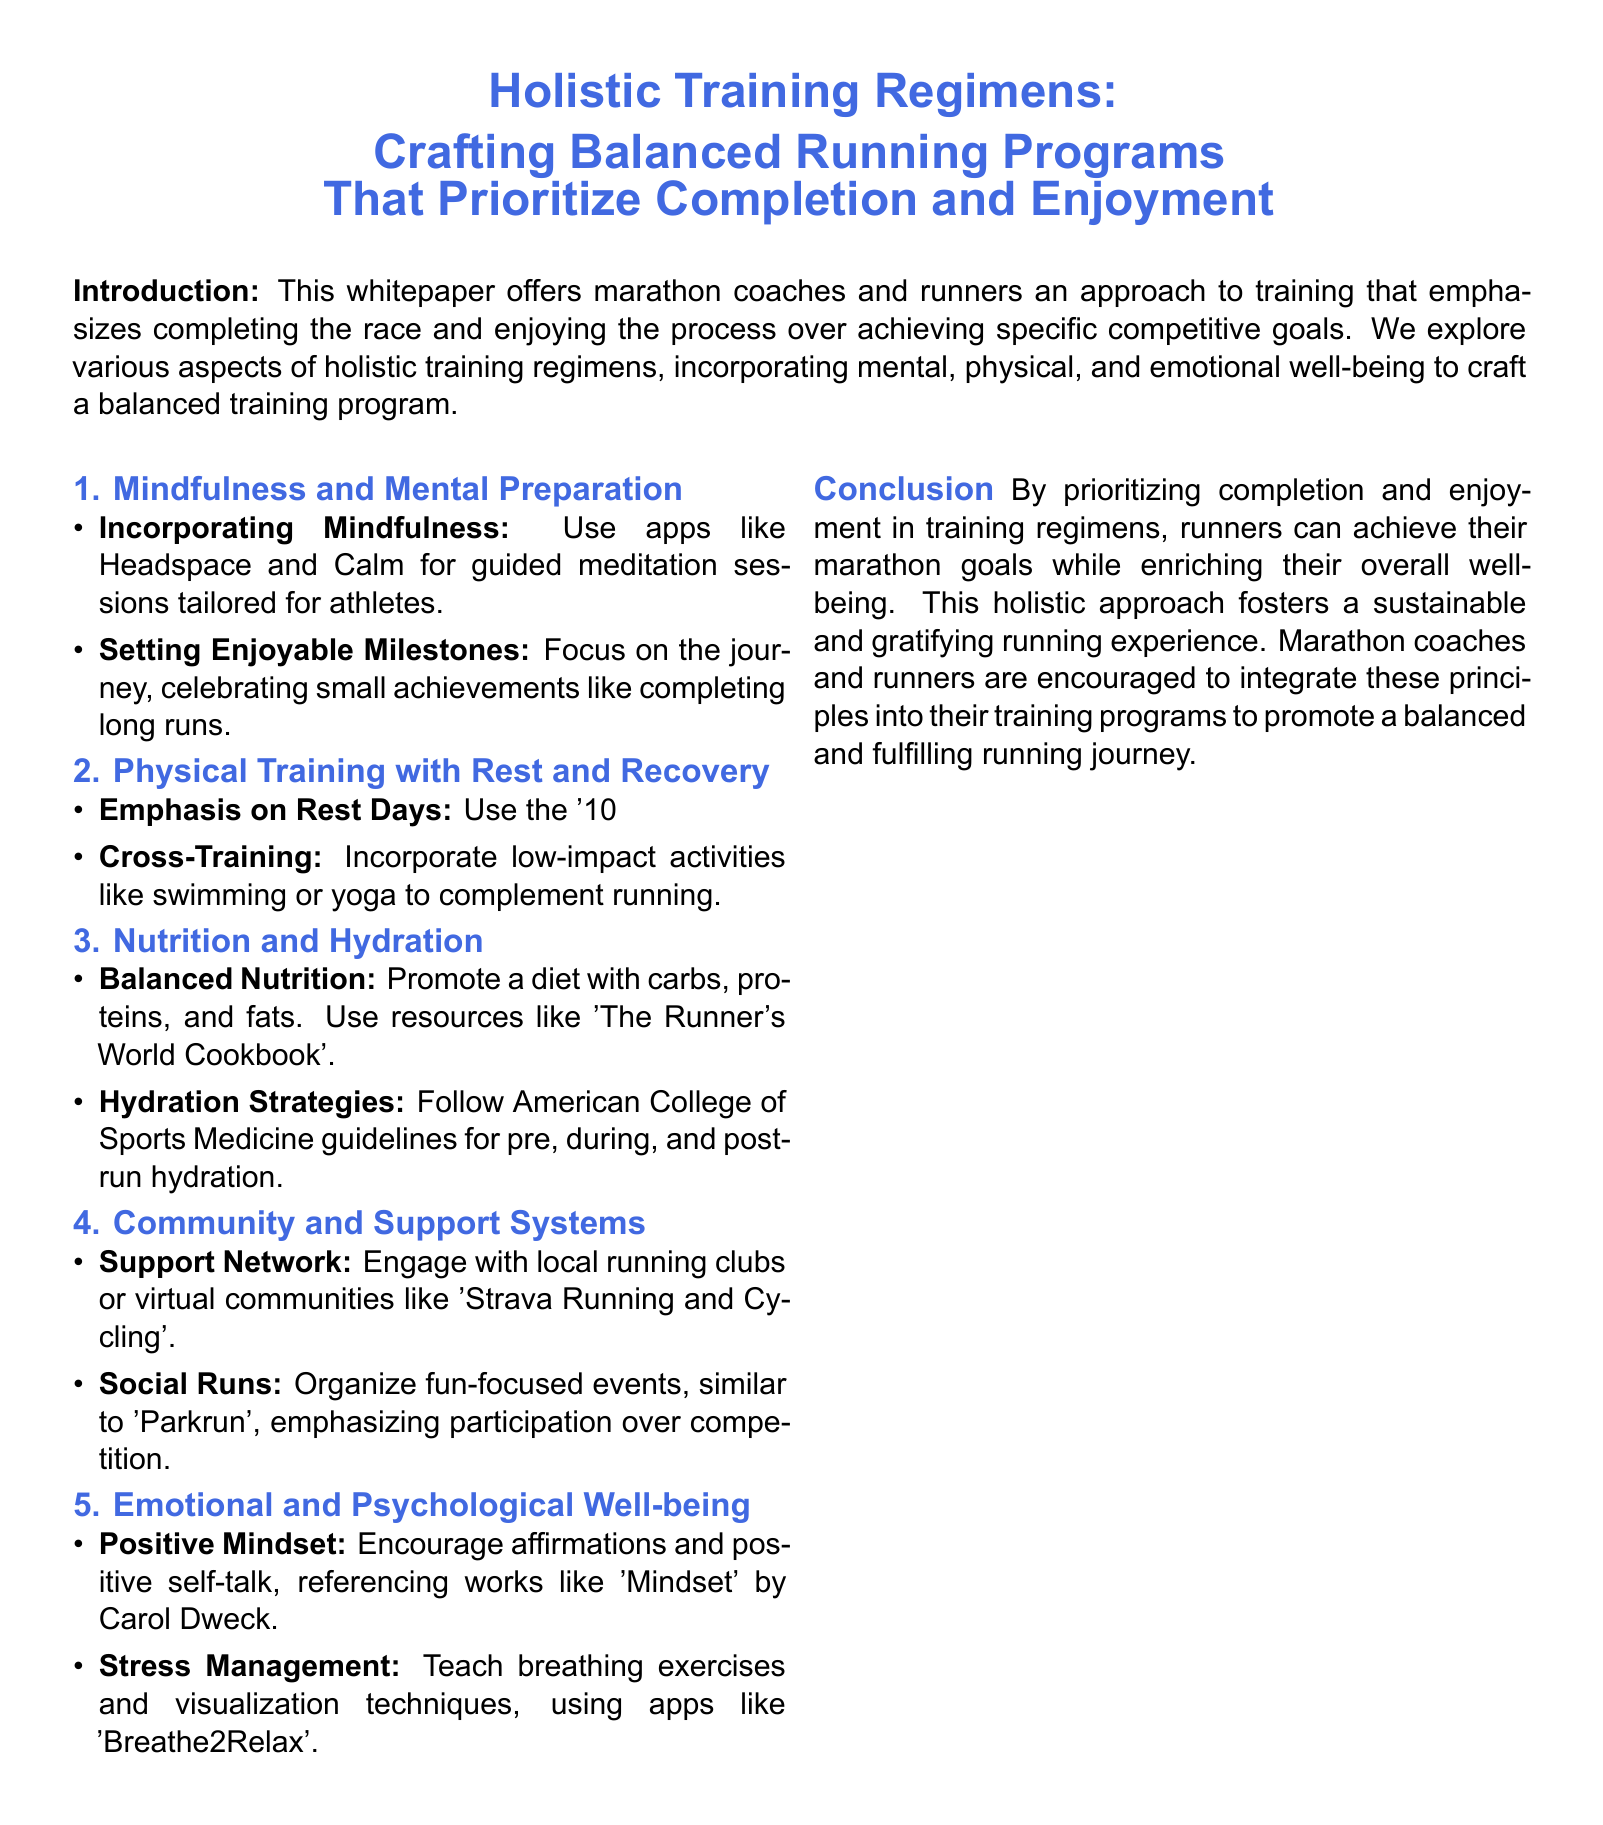What is the primary focus of the training regimens discussed? The focus is on completing the race and enjoying the process over achieving specific competitive goals.
Answer: Completion and enjoyment What are two mindfulness practices suggested in the document? The document suggests using apps like Headspace and Calm for guided meditation sessions tailored for athletes.
Answer: Guided meditation What does the document say about the '10% rule'? The '10% rule' is mentioned as a method to increase mileage gradually and prevent overtraining.
Answer: Prevent overtraining What type of activities are recommended for cross-training? The document recommends incorporating low-impact activities like swimming or yoga.
Answer: Swimming or yoga Which community engagement tool is mentioned for runners? The document mentions engaging with local running clubs or virtual communities like 'Strava Running and Cycling'.
Answer: Strava Running and Cycling What is one nutritional resource recommended in the whitepaper? The document references 'The Runner's World Cookbook' as a resource for balanced nutrition.
Answer: The Runner's World Cookbook How does the whitepaper suggest managing stress? The document suggests teaching breathing exercises and visualization techniques, using apps like 'Breathe2Relax'.
Answer: Breathing exercises What is the conclusion's stance on the training approach? The conclusion emphasizes that this holistic approach fosters a sustainable and gratifying running experience.
Answer: Sustainable and gratifying What is encouraged for emotional well-being according to the document? The document encourages affirmations and positive self-talk as part of emotional well-being.
Answer: Positive self-talk 